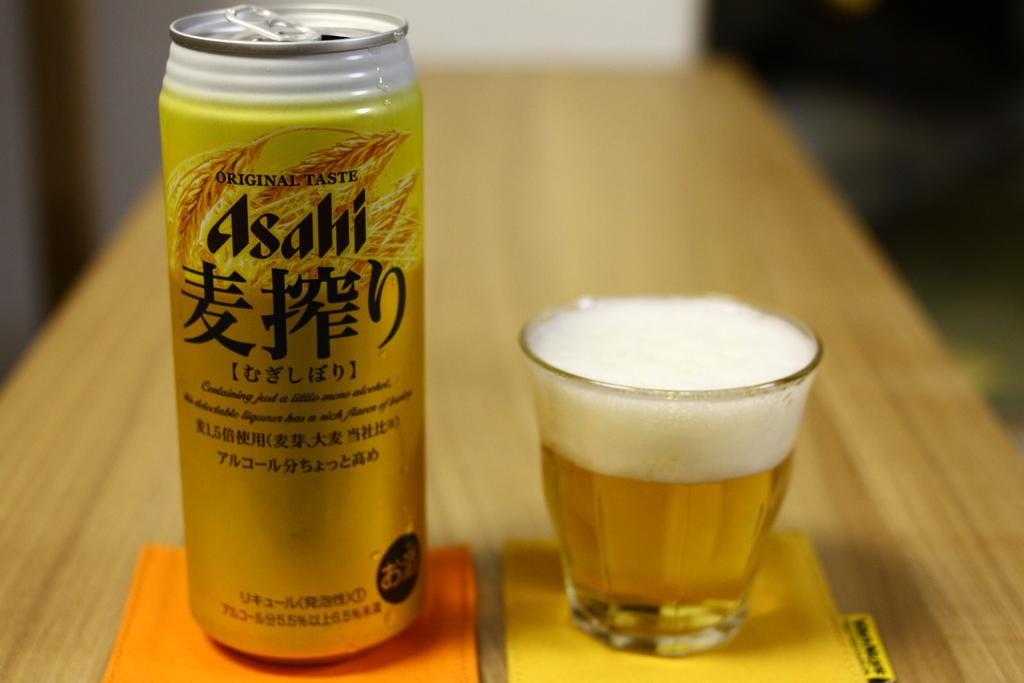<image>
Write a terse but informative summary of the picture. the word asahi that is on a bottle 